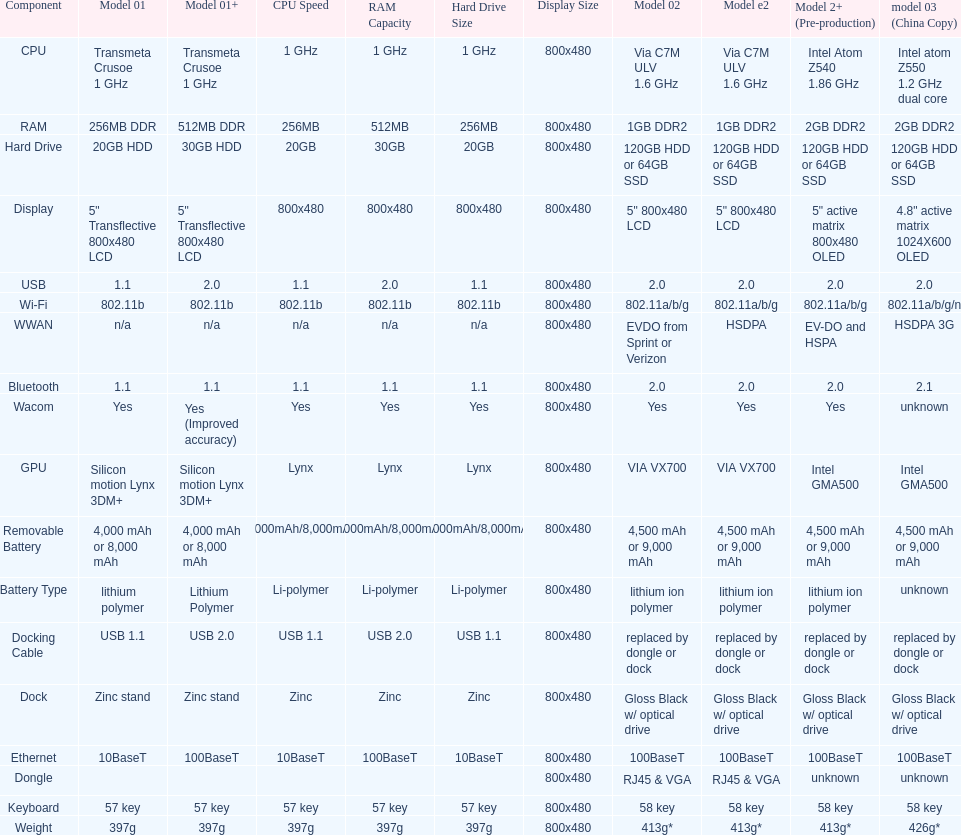Can one identify a minimum of 13 distinct elements on the graph? Yes. 